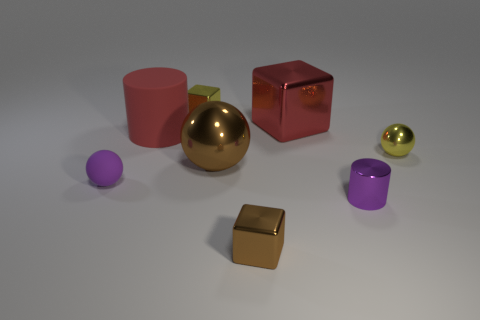Add 1 big brown matte spheres. How many objects exist? 9 Subtract all balls. How many objects are left? 5 Add 6 gray metal things. How many gray metal things exist? 6 Subtract 0 cyan cylinders. How many objects are left? 8 Subtract all large gray shiny cylinders. Subtract all brown spheres. How many objects are left? 7 Add 4 tiny yellow metal balls. How many tiny yellow metal balls are left? 5 